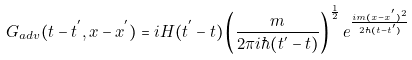<formula> <loc_0><loc_0><loc_500><loc_500>G _ { a d v } ( t - t ^ { ^ { \prime } } , x - x ^ { ^ { \prime } } ) = i H ( t ^ { ^ { \prime } } - t ) \left ( \frac { m } { 2 \pi i \hbar { ( } t ^ { ^ { \prime } } - t ) } \right ) ^ { \frac { 1 } { 2 } } e ^ { \frac { i m ( x - x ^ { ^ { \prime } } ) ^ { 2 } } { 2 \hbar { ( } t - t ^ { ^ { \prime } } ) } }</formula> 